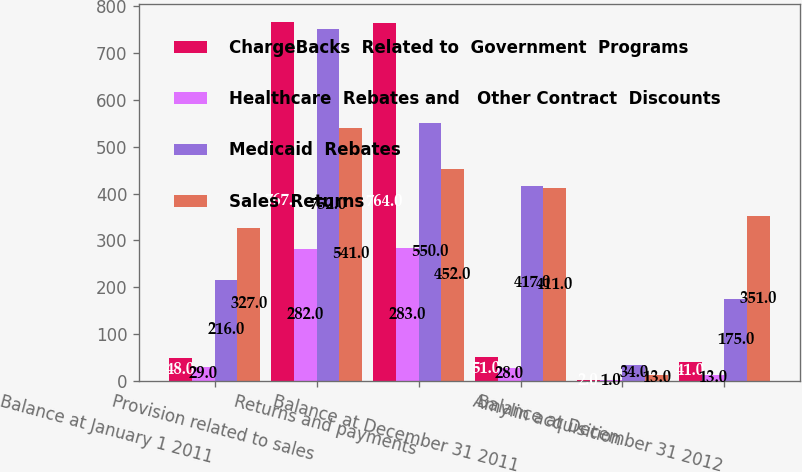Convert chart. <chart><loc_0><loc_0><loc_500><loc_500><stacked_bar_chart><ecel><fcel>Balance at January 1 2011<fcel>Provision related to sales<fcel>Returns and payments<fcel>Balance at December 31 2011<fcel>Amylin acquisition<fcel>Balance at December 31 2012<nl><fcel>ChargeBacks  Related to  Government  Programs<fcel>48<fcel>767<fcel>764<fcel>51<fcel>2<fcel>41<nl><fcel>Healthcare  Rebates and   Other Contract  Discounts<fcel>29<fcel>282<fcel>283<fcel>28<fcel>1<fcel>13<nl><fcel>Medicaid  Rebates<fcel>216<fcel>752<fcel>550<fcel>417<fcel>34<fcel>175<nl><fcel>Sales  Returns<fcel>327<fcel>541<fcel>452<fcel>411<fcel>13<fcel>351<nl></chart> 